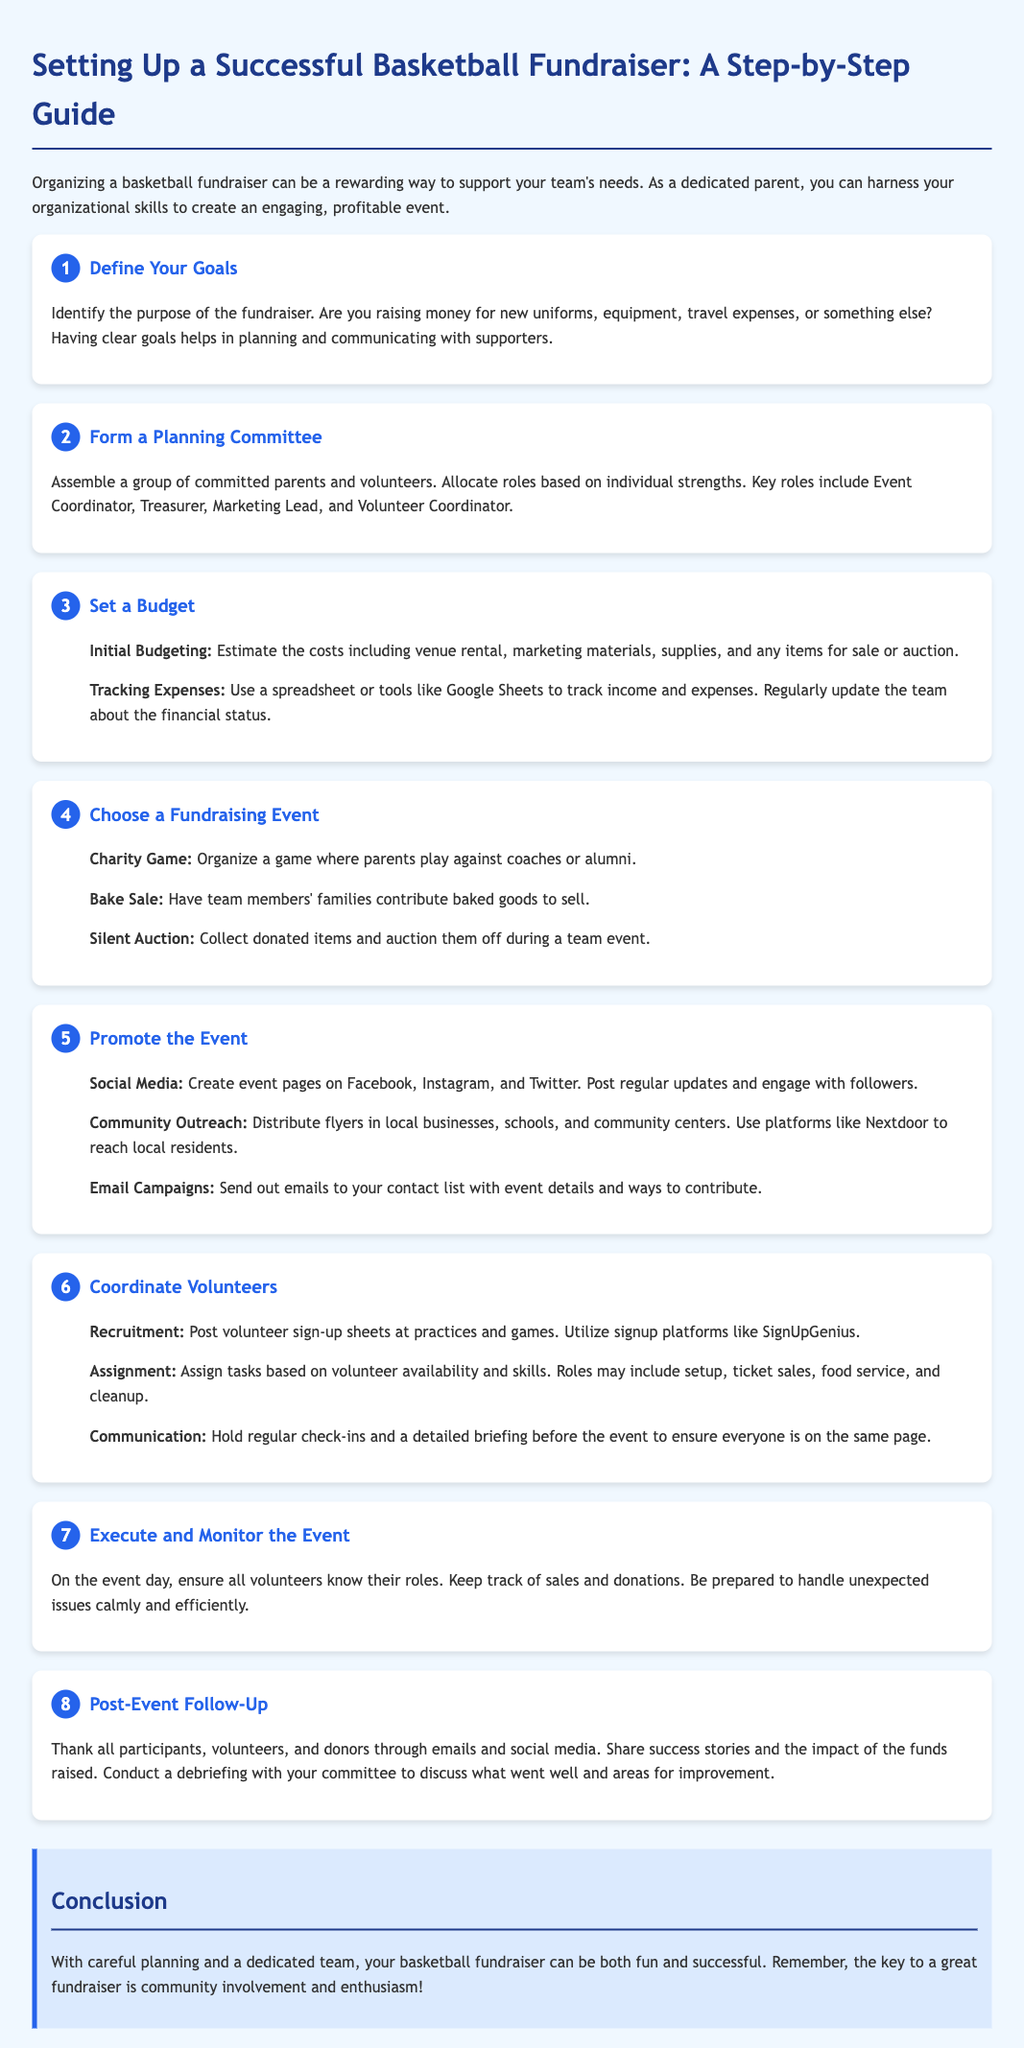what is the first step in setting up a fundraiser? The first step in setting up a fundraiser is to define your goals.
Answer: Define Your Goals who should be in the planning committee? The planning committee should include committed parents and volunteers.
Answer: Committed parents and volunteers what should be tracked in the budget? In the budget, costs such as venue rental, marketing materials, supplies, and items for sale or auction should be tracked.
Answer: Venue rental, marketing materials, supplies, and items for sale or auction how can volunteers be recruited? Volunteers can be recruited by posting sign-up sheets at practices and games.
Answer: Posting sign-up sheets at practices and games what should be done after the event? After the event, thank all participants, volunteers, and donors.
Answer: Thank all participants, volunteers, and donors what is a recommended fundraising event type? A recommended fundraising event type is a charity game.
Answer: Charity game how can the event be promoted? The event can be promoted through social media, community outreach, and email campaigns.
Answer: Social media, community outreach, and email campaigns why is it important to monitor the event execution? It is important to monitor the event execution to ensure all volunteers know their roles and to track sales and donations.
Answer: To ensure all volunteers know their roles and to track sales and donations 